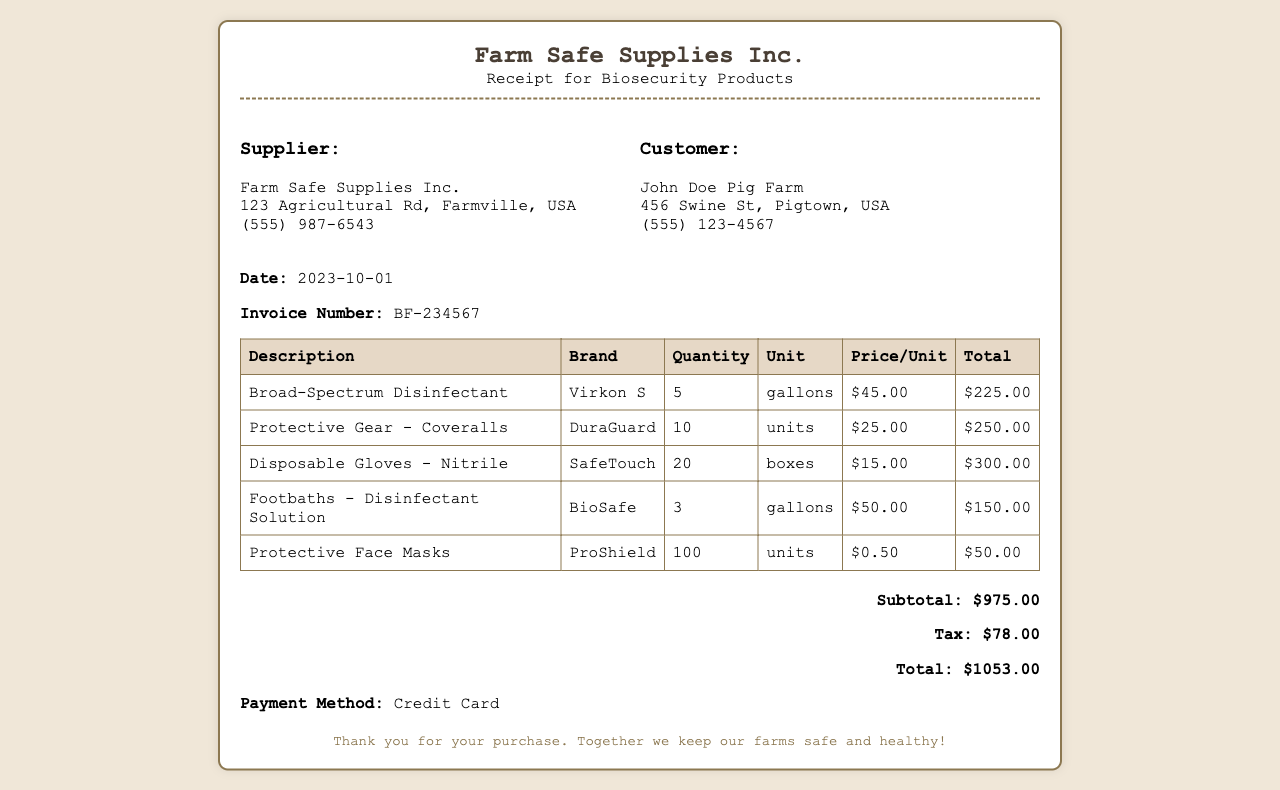What is the date of the receipt? The date is listed clearly in the receipt as the date of purchase.
Answer: 2023-10-01 What is the total amount paid? The total amount reflects the final cost after tax is applied, summarized at the bottom of the receipt.
Answer: $1053.00 How many gallons of Broad-Spectrum Disinfectant were purchased? The quantity of the product is specified in the table of purchased items.
Answer: 5 What is the brand of the Disposable Gloves? The specific brand for the disposable gloves is indicated in the product listing section.
Answer: SafeTouch How many units of Protective Gear - Coveralls were bought? The quantity is found in the table detailing the products, showing how many units were ordered.
Answer: 10 What is the subtotal before taxes? The subtotal represents the total cost of items before tax is added, listed in the summary.
Answer: $975.00 What payment method was used for the purchase? The method of payment is explicitly mentioned at the bottom of the receipt.
Answer: Credit Card What is the brand of the Footbaths - Disinfectant Solution? The brand is included in the product description within the table of purchased items.
Answer: BioSafe How many boxes of Disposable Gloves were ordered? The quantity of boxes is provided in the item listing, detailing the amount ordered.
Answer: 20 